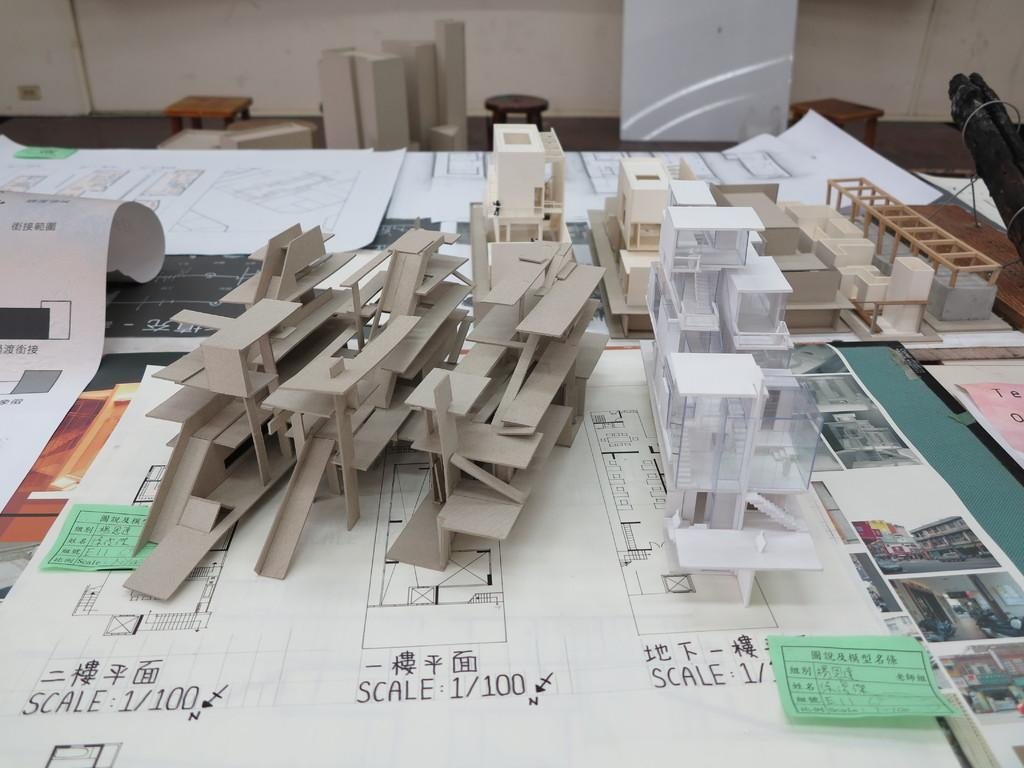<image>
Render a clear and concise summary of the photo. Pieces of building models are stacked on a table, and they are at a scale of 1/100. 